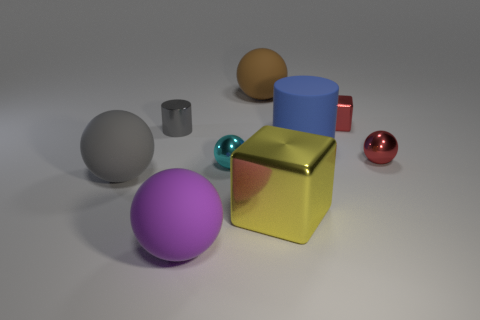What size is the red thing that is the same material as the red ball? The red item that shares the same glossy material as the red ball appears to be small, similar in scale to the cylinder and cube but smaller than the larger balls and blocks in the image. 